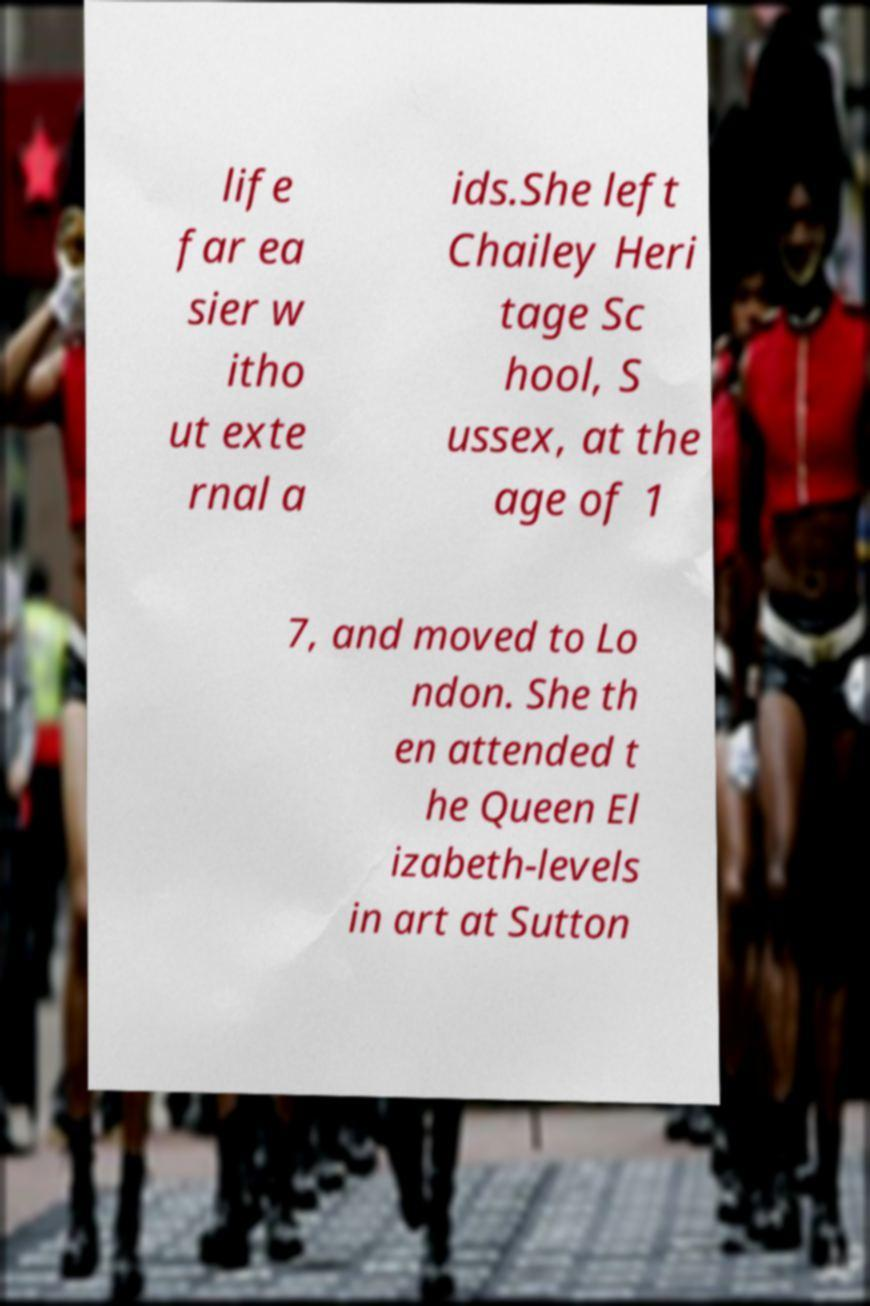For documentation purposes, I need the text within this image transcribed. Could you provide that? life far ea sier w itho ut exte rnal a ids.She left Chailey Heri tage Sc hool, S ussex, at the age of 1 7, and moved to Lo ndon. She th en attended t he Queen El izabeth-levels in art at Sutton 